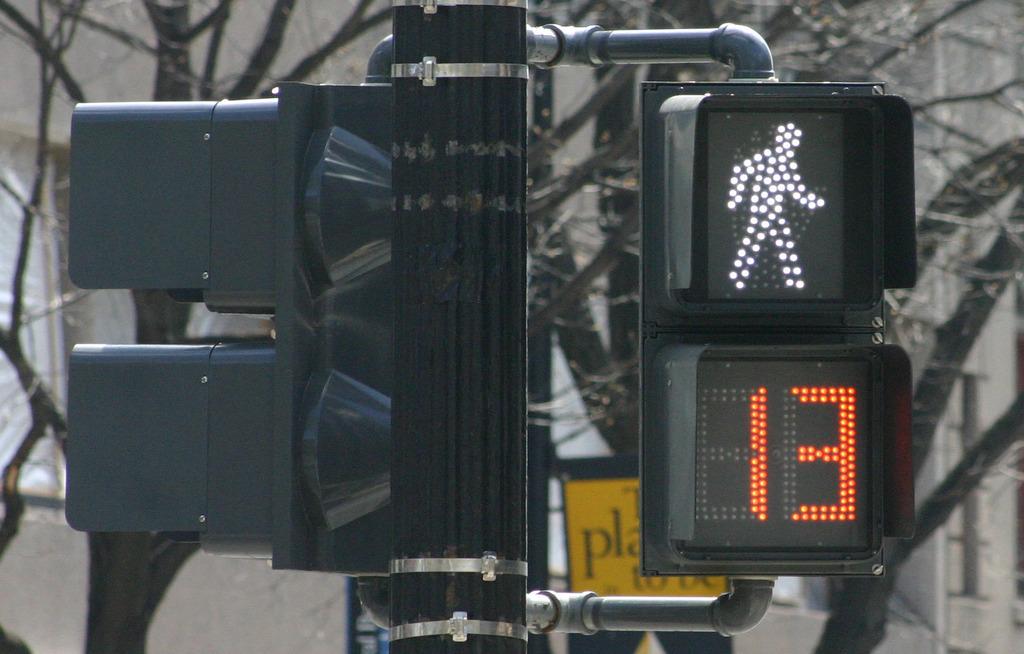How much time is left to cross?
Offer a terse response. 13. What color are the numbers?
Your response must be concise. Orange. 